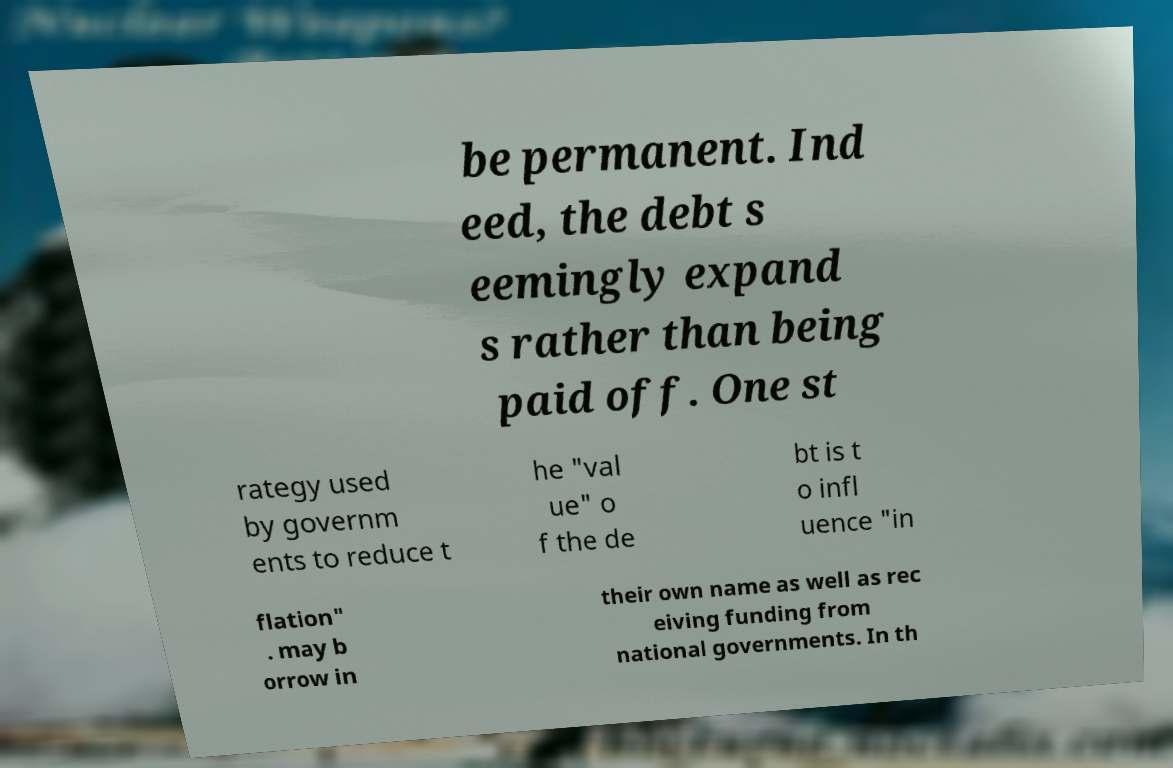For documentation purposes, I need the text within this image transcribed. Could you provide that? be permanent. Ind eed, the debt s eemingly expand s rather than being paid off. One st rategy used by governm ents to reduce t he "val ue" o f the de bt is t o infl uence "in flation" . may b orrow in their own name as well as rec eiving funding from national governments. In th 